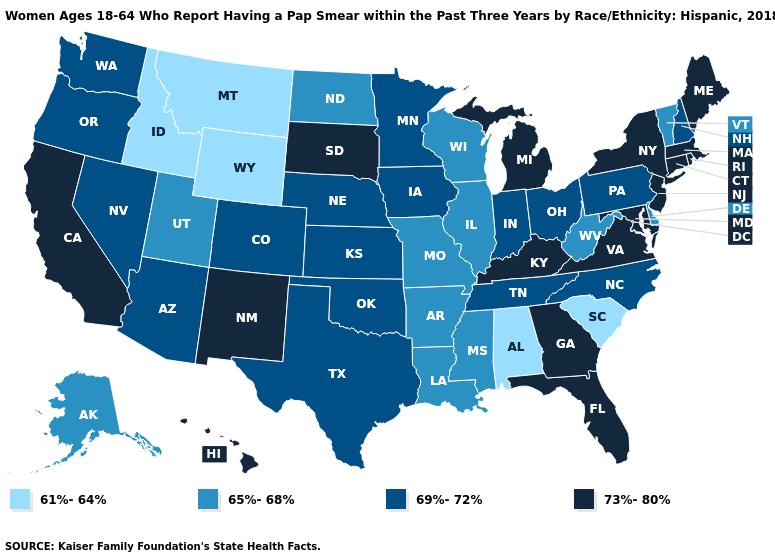Name the states that have a value in the range 73%-80%?
Quick response, please. California, Connecticut, Florida, Georgia, Hawaii, Kentucky, Maine, Maryland, Massachusetts, Michigan, New Jersey, New Mexico, New York, Rhode Island, South Dakota, Virginia. Which states have the lowest value in the USA?
Keep it brief. Alabama, Idaho, Montana, South Carolina, Wyoming. Name the states that have a value in the range 65%-68%?
Be succinct. Alaska, Arkansas, Delaware, Illinois, Louisiana, Mississippi, Missouri, North Dakota, Utah, Vermont, West Virginia, Wisconsin. Does Virginia have the lowest value in the USA?
Quick response, please. No. What is the lowest value in the USA?
Quick response, please. 61%-64%. Name the states that have a value in the range 61%-64%?
Give a very brief answer. Alabama, Idaho, Montana, South Carolina, Wyoming. Name the states that have a value in the range 65%-68%?
Answer briefly. Alaska, Arkansas, Delaware, Illinois, Louisiana, Mississippi, Missouri, North Dakota, Utah, Vermont, West Virginia, Wisconsin. Name the states that have a value in the range 73%-80%?
Keep it brief. California, Connecticut, Florida, Georgia, Hawaii, Kentucky, Maine, Maryland, Massachusetts, Michigan, New Jersey, New Mexico, New York, Rhode Island, South Dakota, Virginia. How many symbols are there in the legend?
Quick response, please. 4. Is the legend a continuous bar?
Keep it brief. No. Does the first symbol in the legend represent the smallest category?
Write a very short answer. Yes. Which states have the highest value in the USA?
Concise answer only. California, Connecticut, Florida, Georgia, Hawaii, Kentucky, Maine, Maryland, Massachusetts, Michigan, New Jersey, New Mexico, New York, Rhode Island, South Dakota, Virginia. Name the states that have a value in the range 61%-64%?
Give a very brief answer. Alabama, Idaho, Montana, South Carolina, Wyoming. Does the map have missing data?
Answer briefly. No. What is the value of Louisiana?
Keep it brief. 65%-68%. 